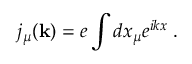Convert formula to latex. <formula><loc_0><loc_0><loc_500><loc_500>j _ { \mu } ( { k } ) = e \int d x _ { \mu } e ^ { i k x } \, .</formula> 